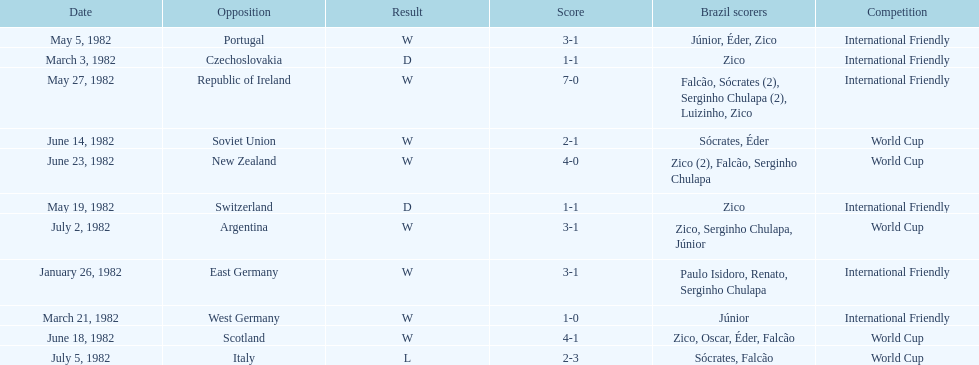Who was this team's next opponent after facing the soviet union on june 14? Scotland. 